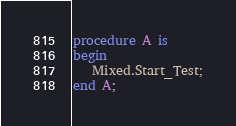Convert code to text. <code><loc_0><loc_0><loc_500><loc_500><_Ada_>procedure A is
begin
   Mixed.Start_Test;
end A;
</code> 